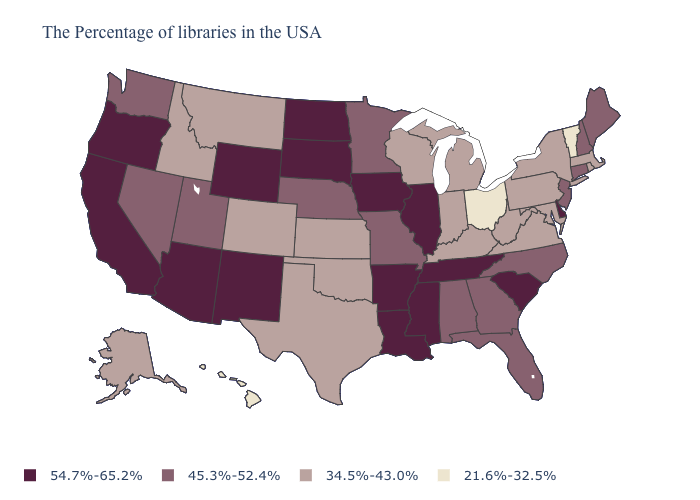Does the first symbol in the legend represent the smallest category?
Short answer required. No. Name the states that have a value in the range 21.6%-32.5%?
Short answer required. Vermont, Ohio, Hawaii. What is the value of Georgia?
Answer briefly. 45.3%-52.4%. Which states have the lowest value in the USA?
Write a very short answer. Vermont, Ohio, Hawaii. What is the value of Connecticut?
Answer briefly. 45.3%-52.4%. Does the first symbol in the legend represent the smallest category?
Quick response, please. No. Does Kansas have a lower value than Hawaii?
Keep it brief. No. Which states have the lowest value in the South?
Be succinct. Maryland, Virginia, West Virginia, Kentucky, Oklahoma, Texas. What is the value of New Hampshire?
Be succinct. 45.3%-52.4%. What is the highest value in the South ?
Short answer required. 54.7%-65.2%. What is the lowest value in the USA?
Give a very brief answer. 21.6%-32.5%. Does Washington have the same value as Mississippi?
Concise answer only. No. Name the states that have a value in the range 45.3%-52.4%?
Give a very brief answer. Maine, New Hampshire, Connecticut, New Jersey, North Carolina, Florida, Georgia, Alabama, Missouri, Minnesota, Nebraska, Utah, Nevada, Washington. What is the lowest value in states that border Arizona?
Short answer required. 34.5%-43.0%. Does Illinois have the highest value in the MidWest?
Give a very brief answer. Yes. 